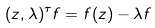Convert formula to latex. <formula><loc_0><loc_0><loc_500><loc_500>( z , \lambda ) ^ { \tau } f = f ( z ) - \lambda f</formula> 